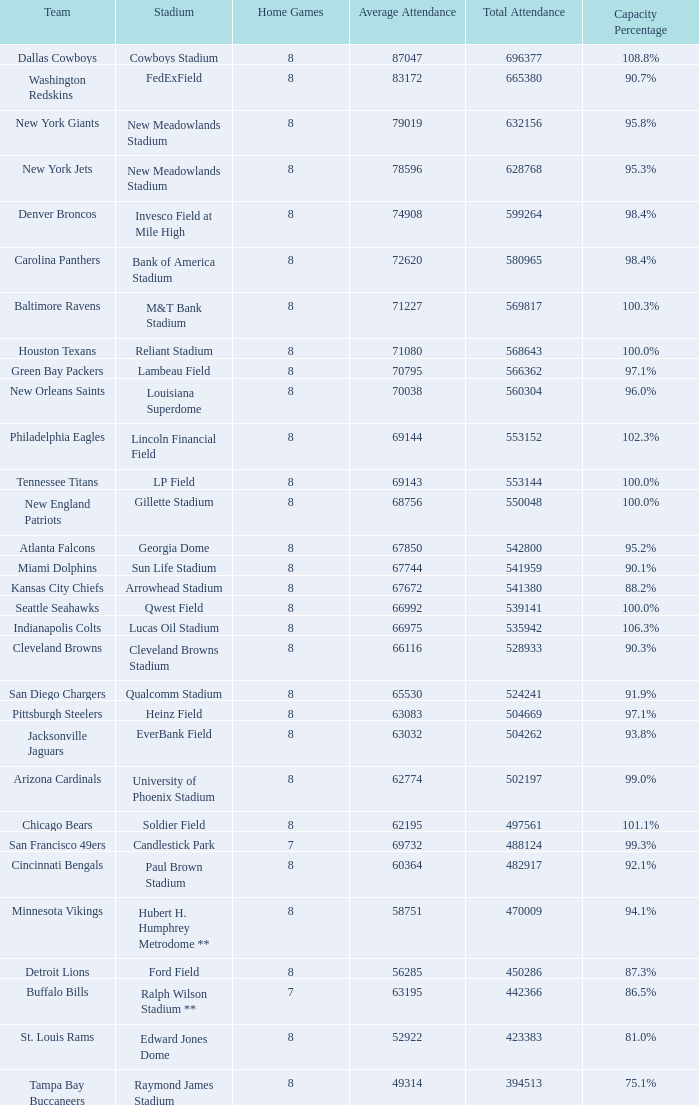With a cumulative attendance of 541,380, what was the average attendance? 67672.0. 